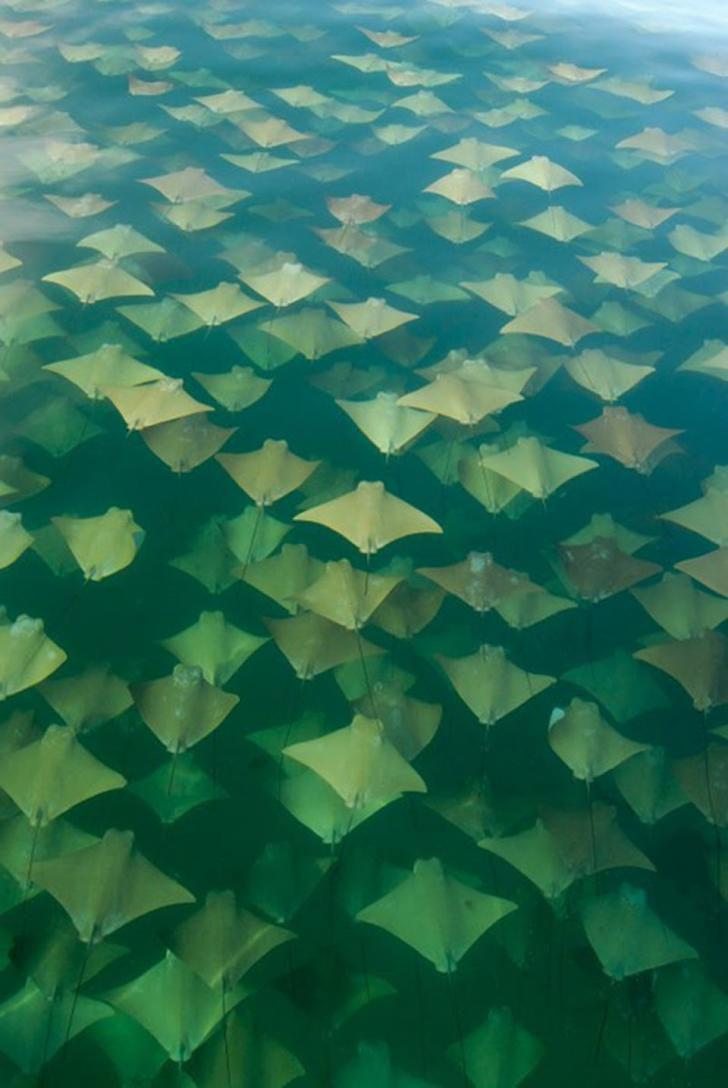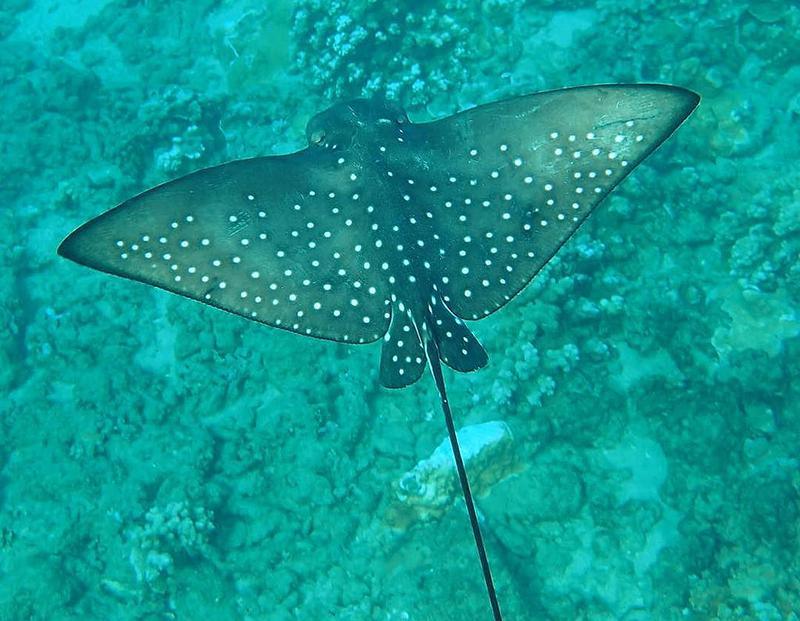The first image is the image on the left, the second image is the image on the right. Assess this claim about the two images: "One stingray with a spotted pattern is included in the right image.". Correct or not? Answer yes or no. Yes. The first image is the image on the left, the second image is the image on the right. Evaluate the accuracy of this statement regarding the images: "One of the images contains exactly one stingray.". Is it true? Answer yes or no. Yes. 